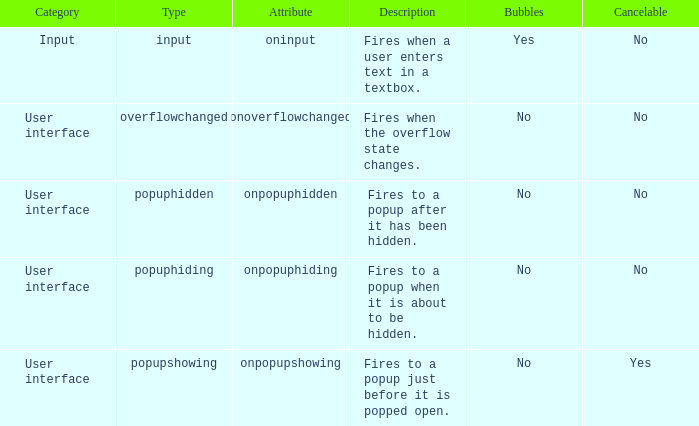What's the bubbles possessing the feature of being onpopuphidden? No. 